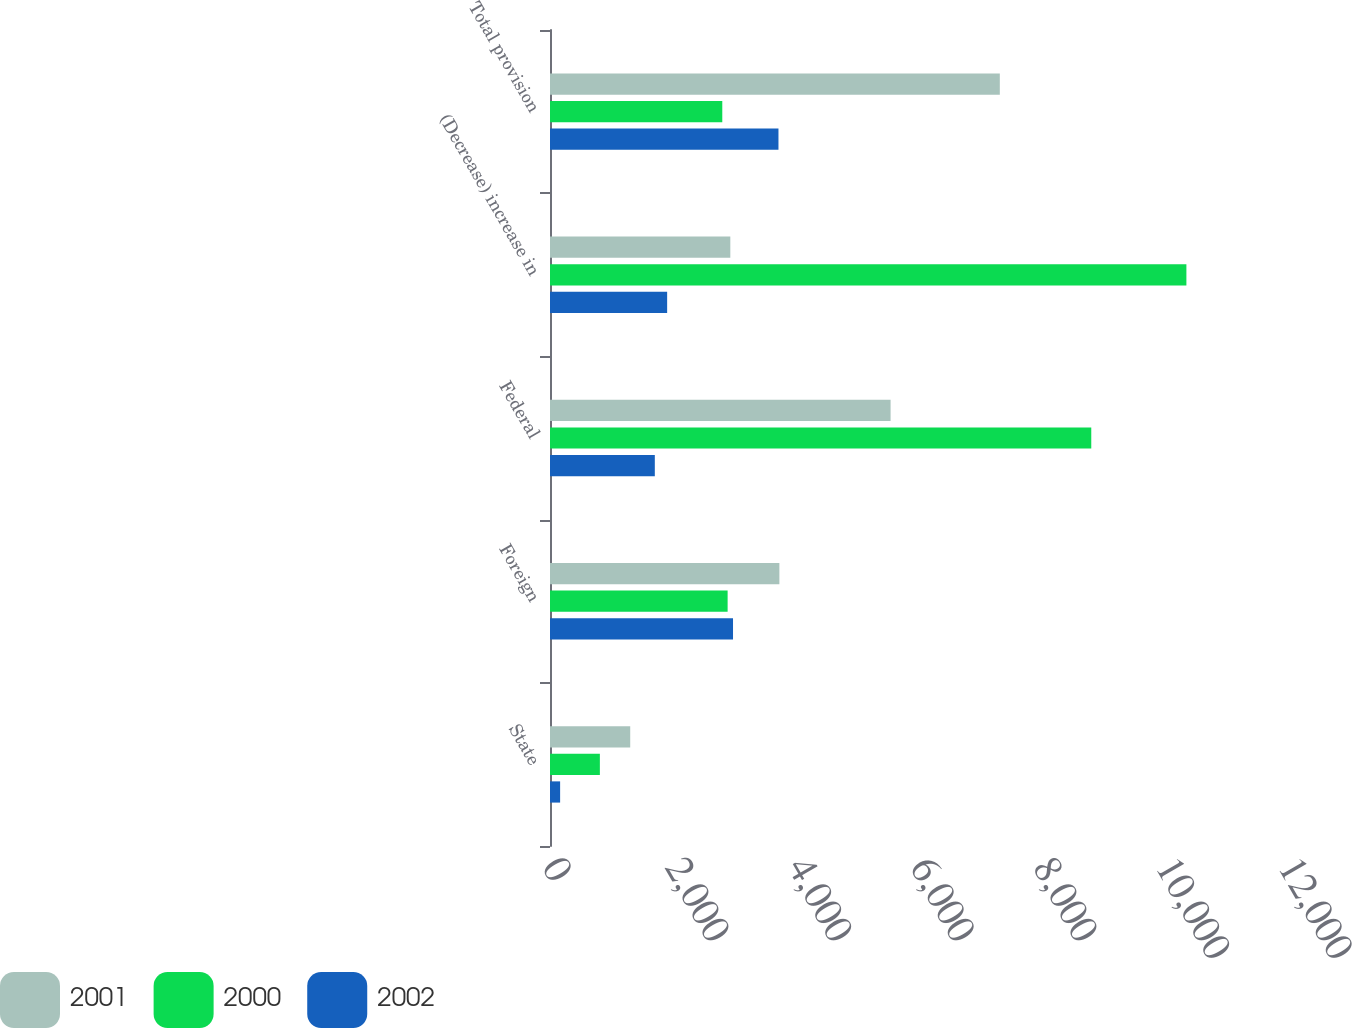Convert chart to OTSL. <chart><loc_0><loc_0><loc_500><loc_500><stacked_bar_chart><ecel><fcel>State<fcel>Foreign<fcel>Federal<fcel>(Decrease) increase in<fcel>Total provision<nl><fcel>2001<fcel>1308<fcel>3740<fcel>5553<fcel>2940<fcel>7334<nl><fcel>2000<fcel>813<fcel>2896<fcel>8825<fcel>10376<fcel>2809<nl><fcel>2002<fcel>165<fcel>2984<fcel>1709<fcel>1910<fcel>3725<nl></chart> 